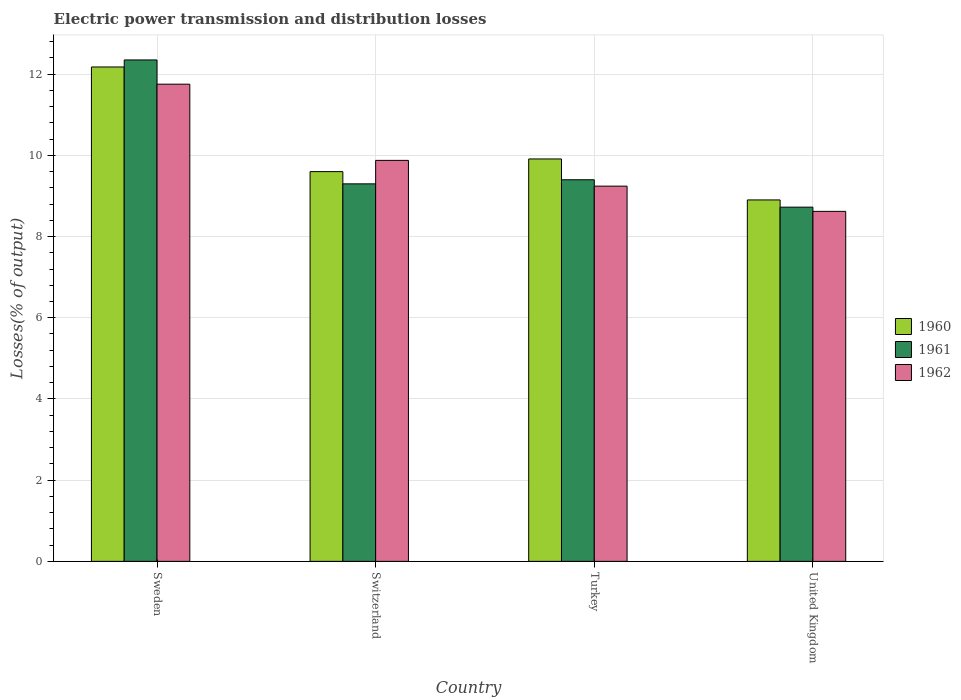Are the number of bars on each tick of the X-axis equal?
Provide a succinct answer. Yes. How many bars are there on the 3rd tick from the right?
Give a very brief answer. 3. What is the electric power transmission and distribution losses in 1960 in Turkey?
Your response must be concise. 9.91. Across all countries, what is the maximum electric power transmission and distribution losses in 1960?
Give a very brief answer. 12.18. Across all countries, what is the minimum electric power transmission and distribution losses in 1960?
Keep it short and to the point. 8.9. In which country was the electric power transmission and distribution losses in 1962 maximum?
Provide a short and direct response. Sweden. In which country was the electric power transmission and distribution losses in 1962 minimum?
Offer a terse response. United Kingdom. What is the total electric power transmission and distribution losses in 1961 in the graph?
Offer a terse response. 39.77. What is the difference between the electric power transmission and distribution losses in 1962 in Turkey and that in United Kingdom?
Your answer should be very brief. 0.62. What is the difference between the electric power transmission and distribution losses in 1960 in Switzerland and the electric power transmission and distribution losses in 1961 in Turkey?
Give a very brief answer. 0.2. What is the average electric power transmission and distribution losses in 1961 per country?
Offer a very short reply. 9.94. What is the difference between the electric power transmission and distribution losses of/in 1961 and electric power transmission and distribution losses of/in 1962 in Switzerland?
Your response must be concise. -0.58. In how many countries, is the electric power transmission and distribution losses in 1960 greater than 1.6 %?
Offer a terse response. 4. What is the ratio of the electric power transmission and distribution losses in 1962 in Switzerland to that in Turkey?
Give a very brief answer. 1.07. What is the difference between the highest and the second highest electric power transmission and distribution losses in 1960?
Make the answer very short. -2.27. What is the difference between the highest and the lowest electric power transmission and distribution losses in 1961?
Provide a succinct answer. 3.63. In how many countries, is the electric power transmission and distribution losses in 1960 greater than the average electric power transmission and distribution losses in 1960 taken over all countries?
Provide a succinct answer. 1. How many bars are there?
Keep it short and to the point. 12. Are all the bars in the graph horizontal?
Your answer should be very brief. No. How many countries are there in the graph?
Your answer should be very brief. 4. What is the difference between two consecutive major ticks on the Y-axis?
Offer a terse response. 2. Are the values on the major ticks of Y-axis written in scientific E-notation?
Give a very brief answer. No. Does the graph contain grids?
Provide a succinct answer. Yes. How many legend labels are there?
Provide a succinct answer. 3. What is the title of the graph?
Keep it short and to the point. Electric power transmission and distribution losses. Does "1974" appear as one of the legend labels in the graph?
Offer a very short reply. No. What is the label or title of the X-axis?
Provide a short and direct response. Country. What is the label or title of the Y-axis?
Provide a succinct answer. Losses(% of output). What is the Losses(% of output) of 1960 in Sweden?
Give a very brief answer. 12.18. What is the Losses(% of output) of 1961 in Sweden?
Keep it short and to the point. 12.35. What is the Losses(% of output) of 1962 in Sweden?
Give a very brief answer. 11.75. What is the Losses(% of output) in 1960 in Switzerland?
Your answer should be very brief. 9.6. What is the Losses(% of output) of 1961 in Switzerland?
Your answer should be very brief. 9.3. What is the Losses(% of output) of 1962 in Switzerland?
Offer a terse response. 9.88. What is the Losses(% of output) in 1960 in Turkey?
Your answer should be very brief. 9.91. What is the Losses(% of output) of 1961 in Turkey?
Your answer should be very brief. 9.4. What is the Losses(% of output) of 1962 in Turkey?
Offer a very short reply. 9.24. What is the Losses(% of output) in 1960 in United Kingdom?
Give a very brief answer. 8.9. What is the Losses(% of output) of 1961 in United Kingdom?
Give a very brief answer. 8.72. What is the Losses(% of output) of 1962 in United Kingdom?
Provide a succinct answer. 8.62. Across all countries, what is the maximum Losses(% of output) in 1960?
Your answer should be very brief. 12.18. Across all countries, what is the maximum Losses(% of output) of 1961?
Keep it short and to the point. 12.35. Across all countries, what is the maximum Losses(% of output) of 1962?
Provide a succinct answer. 11.75. Across all countries, what is the minimum Losses(% of output) in 1960?
Keep it short and to the point. 8.9. Across all countries, what is the minimum Losses(% of output) in 1961?
Keep it short and to the point. 8.72. Across all countries, what is the minimum Losses(% of output) of 1962?
Offer a terse response. 8.62. What is the total Losses(% of output) in 1960 in the graph?
Give a very brief answer. 40.59. What is the total Losses(% of output) in 1961 in the graph?
Keep it short and to the point. 39.77. What is the total Losses(% of output) in 1962 in the graph?
Provide a short and direct response. 39.49. What is the difference between the Losses(% of output) in 1960 in Sweden and that in Switzerland?
Offer a very short reply. 2.58. What is the difference between the Losses(% of output) in 1961 in Sweden and that in Switzerland?
Ensure brevity in your answer.  3.05. What is the difference between the Losses(% of output) of 1962 in Sweden and that in Switzerland?
Your answer should be compact. 1.88. What is the difference between the Losses(% of output) in 1960 in Sweden and that in Turkey?
Your response must be concise. 2.27. What is the difference between the Losses(% of output) of 1961 in Sweden and that in Turkey?
Make the answer very short. 2.95. What is the difference between the Losses(% of output) of 1962 in Sweden and that in Turkey?
Make the answer very short. 2.51. What is the difference between the Losses(% of output) of 1960 in Sweden and that in United Kingdom?
Make the answer very short. 3.27. What is the difference between the Losses(% of output) of 1961 in Sweden and that in United Kingdom?
Offer a terse response. 3.63. What is the difference between the Losses(% of output) in 1962 in Sweden and that in United Kingdom?
Offer a very short reply. 3.13. What is the difference between the Losses(% of output) in 1960 in Switzerland and that in Turkey?
Give a very brief answer. -0.31. What is the difference between the Losses(% of output) of 1961 in Switzerland and that in Turkey?
Ensure brevity in your answer.  -0.1. What is the difference between the Losses(% of output) in 1962 in Switzerland and that in Turkey?
Offer a terse response. 0.63. What is the difference between the Losses(% of output) of 1960 in Switzerland and that in United Kingdom?
Give a very brief answer. 0.7. What is the difference between the Losses(% of output) of 1961 in Switzerland and that in United Kingdom?
Ensure brevity in your answer.  0.57. What is the difference between the Losses(% of output) in 1962 in Switzerland and that in United Kingdom?
Provide a succinct answer. 1.26. What is the difference between the Losses(% of output) in 1960 in Turkey and that in United Kingdom?
Make the answer very short. 1.01. What is the difference between the Losses(% of output) in 1961 in Turkey and that in United Kingdom?
Provide a succinct answer. 0.68. What is the difference between the Losses(% of output) of 1962 in Turkey and that in United Kingdom?
Your answer should be compact. 0.62. What is the difference between the Losses(% of output) in 1960 in Sweden and the Losses(% of output) in 1961 in Switzerland?
Your response must be concise. 2.88. What is the difference between the Losses(% of output) in 1960 in Sweden and the Losses(% of output) in 1962 in Switzerland?
Offer a very short reply. 2.3. What is the difference between the Losses(% of output) in 1961 in Sweden and the Losses(% of output) in 1962 in Switzerland?
Offer a terse response. 2.47. What is the difference between the Losses(% of output) in 1960 in Sweden and the Losses(% of output) in 1961 in Turkey?
Your answer should be compact. 2.78. What is the difference between the Losses(% of output) in 1960 in Sweden and the Losses(% of output) in 1962 in Turkey?
Make the answer very short. 2.94. What is the difference between the Losses(% of output) of 1961 in Sweden and the Losses(% of output) of 1962 in Turkey?
Your answer should be compact. 3.11. What is the difference between the Losses(% of output) in 1960 in Sweden and the Losses(% of output) in 1961 in United Kingdom?
Provide a succinct answer. 3.45. What is the difference between the Losses(% of output) of 1960 in Sweden and the Losses(% of output) of 1962 in United Kingdom?
Provide a succinct answer. 3.56. What is the difference between the Losses(% of output) in 1961 in Sweden and the Losses(% of output) in 1962 in United Kingdom?
Make the answer very short. 3.73. What is the difference between the Losses(% of output) of 1960 in Switzerland and the Losses(% of output) of 1961 in Turkey?
Provide a short and direct response. 0.2. What is the difference between the Losses(% of output) of 1960 in Switzerland and the Losses(% of output) of 1962 in Turkey?
Make the answer very short. 0.36. What is the difference between the Losses(% of output) in 1961 in Switzerland and the Losses(% of output) in 1962 in Turkey?
Your response must be concise. 0.06. What is the difference between the Losses(% of output) in 1960 in Switzerland and the Losses(% of output) in 1961 in United Kingdom?
Provide a succinct answer. 0.88. What is the difference between the Losses(% of output) in 1960 in Switzerland and the Losses(% of output) in 1962 in United Kingdom?
Provide a succinct answer. 0.98. What is the difference between the Losses(% of output) of 1961 in Switzerland and the Losses(% of output) of 1962 in United Kingdom?
Make the answer very short. 0.68. What is the difference between the Losses(% of output) in 1960 in Turkey and the Losses(% of output) in 1961 in United Kingdom?
Make the answer very short. 1.19. What is the difference between the Losses(% of output) in 1960 in Turkey and the Losses(% of output) in 1962 in United Kingdom?
Make the answer very short. 1.29. What is the difference between the Losses(% of output) in 1961 in Turkey and the Losses(% of output) in 1962 in United Kingdom?
Your answer should be compact. 0.78. What is the average Losses(% of output) in 1960 per country?
Provide a succinct answer. 10.15. What is the average Losses(% of output) in 1961 per country?
Your answer should be compact. 9.94. What is the average Losses(% of output) in 1962 per country?
Offer a very short reply. 9.87. What is the difference between the Losses(% of output) in 1960 and Losses(% of output) in 1961 in Sweden?
Provide a short and direct response. -0.17. What is the difference between the Losses(% of output) in 1960 and Losses(% of output) in 1962 in Sweden?
Your response must be concise. 0.42. What is the difference between the Losses(% of output) in 1961 and Losses(% of output) in 1962 in Sweden?
Keep it short and to the point. 0.6. What is the difference between the Losses(% of output) of 1960 and Losses(% of output) of 1961 in Switzerland?
Provide a succinct answer. 0.3. What is the difference between the Losses(% of output) in 1960 and Losses(% of output) in 1962 in Switzerland?
Your answer should be very brief. -0.28. What is the difference between the Losses(% of output) of 1961 and Losses(% of output) of 1962 in Switzerland?
Your answer should be compact. -0.58. What is the difference between the Losses(% of output) of 1960 and Losses(% of output) of 1961 in Turkey?
Offer a very short reply. 0.51. What is the difference between the Losses(% of output) of 1960 and Losses(% of output) of 1962 in Turkey?
Your response must be concise. 0.67. What is the difference between the Losses(% of output) of 1961 and Losses(% of output) of 1962 in Turkey?
Give a very brief answer. 0.16. What is the difference between the Losses(% of output) in 1960 and Losses(% of output) in 1961 in United Kingdom?
Ensure brevity in your answer.  0.18. What is the difference between the Losses(% of output) of 1960 and Losses(% of output) of 1962 in United Kingdom?
Ensure brevity in your answer.  0.28. What is the difference between the Losses(% of output) of 1961 and Losses(% of output) of 1962 in United Kingdom?
Your response must be concise. 0.1. What is the ratio of the Losses(% of output) in 1960 in Sweden to that in Switzerland?
Provide a short and direct response. 1.27. What is the ratio of the Losses(% of output) of 1961 in Sweden to that in Switzerland?
Your response must be concise. 1.33. What is the ratio of the Losses(% of output) in 1962 in Sweden to that in Switzerland?
Offer a terse response. 1.19. What is the ratio of the Losses(% of output) in 1960 in Sweden to that in Turkey?
Offer a terse response. 1.23. What is the ratio of the Losses(% of output) of 1961 in Sweden to that in Turkey?
Make the answer very short. 1.31. What is the ratio of the Losses(% of output) of 1962 in Sweden to that in Turkey?
Provide a short and direct response. 1.27. What is the ratio of the Losses(% of output) in 1960 in Sweden to that in United Kingdom?
Your response must be concise. 1.37. What is the ratio of the Losses(% of output) of 1961 in Sweden to that in United Kingdom?
Give a very brief answer. 1.42. What is the ratio of the Losses(% of output) in 1962 in Sweden to that in United Kingdom?
Your response must be concise. 1.36. What is the ratio of the Losses(% of output) of 1960 in Switzerland to that in Turkey?
Your answer should be very brief. 0.97. What is the ratio of the Losses(% of output) of 1961 in Switzerland to that in Turkey?
Give a very brief answer. 0.99. What is the ratio of the Losses(% of output) in 1962 in Switzerland to that in Turkey?
Your response must be concise. 1.07. What is the ratio of the Losses(% of output) of 1960 in Switzerland to that in United Kingdom?
Your answer should be compact. 1.08. What is the ratio of the Losses(% of output) of 1961 in Switzerland to that in United Kingdom?
Make the answer very short. 1.07. What is the ratio of the Losses(% of output) in 1962 in Switzerland to that in United Kingdom?
Your answer should be compact. 1.15. What is the ratio of the Losses(% of output) in 1960 in Turkey to that in United Kingdom?
Offer a terse response. 1.11. What is the ratio of the Losses(% of output) in 1961 in Turkey to that in United Kingdom?
Ensure brevity in your answer.  1.08. What is the ratio of the Losses(% of output) in 1962 in Turkey to that in United Kingdom?
Your response must be concise. 1.07. What is the difference between the highest and the second highest Losses(% of output) of 1960?
Provide a succinct answer. 2.27. What is the difference between the highest and the second highest Losses(% of output) of 1961?
Provide a succinct answer. 2.95. What is the difference between the highest and the second highest Losses(% of output) in 1962?
Provide a short and direct response. 1.88. What is the difference between the highest and the lowest Losses(% of output) of 1960?
Offer a terse response. 3.27. What is the difference between the highest and the lowest Losses(% of output) of 1961?
Provide a short and direct response. 3.63. What is the difference between the highest and the lowest Losses(% of output) in 1962?
Your response must be concise. 3.13. 